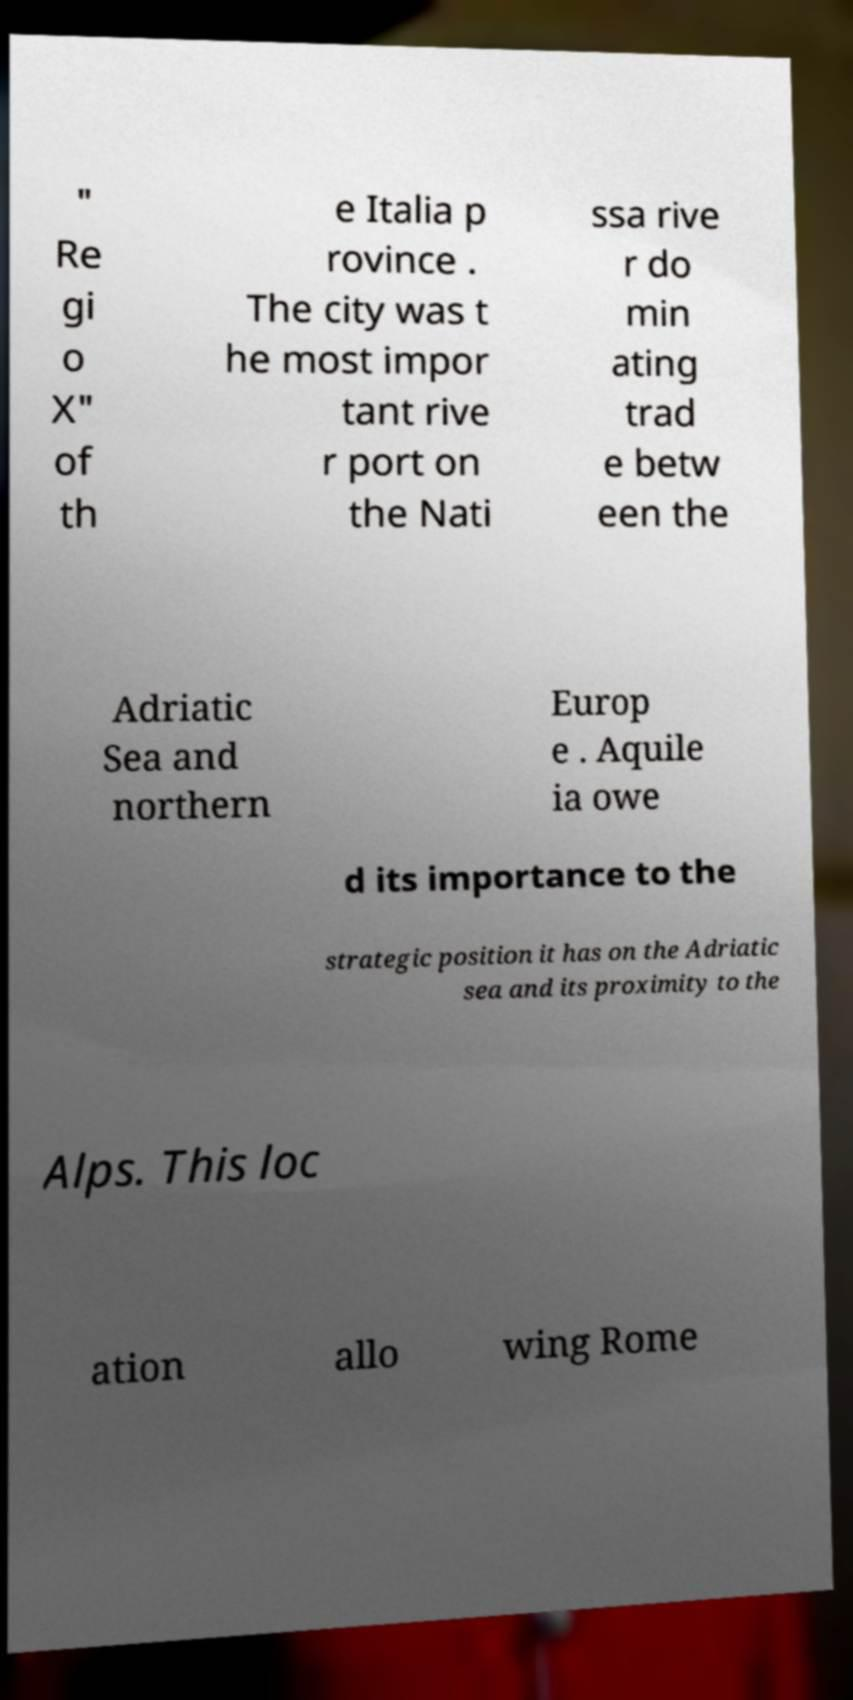I need the written content from this picture converted into text. Can you do that? " Re gi o X" of th e Italia p rovince . The city was t he most impor tant rive r port on the Nati ssa rive r do min ating trad e betw een the Adriatic Sea and northern Europ e . Aquile ia owe d its importance to the strategic position it has on the Adriatic sea and its proximity to the Alps. This loc ation allo wing Rome 